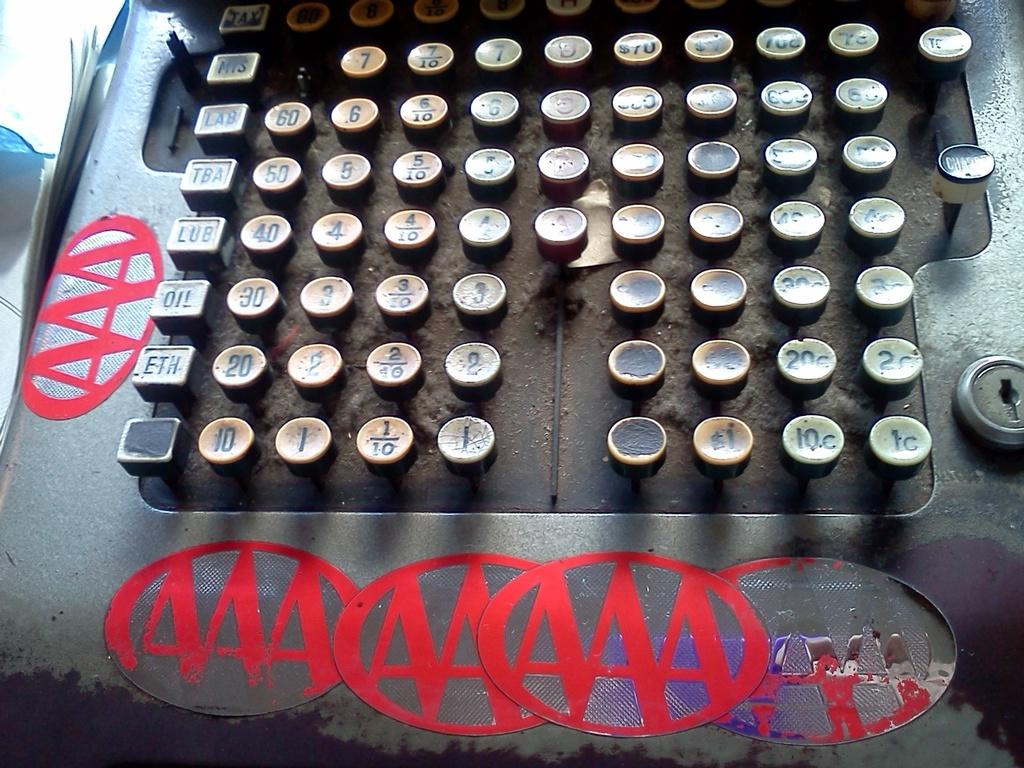<image>
Summarize the visual content of the image. An antique cash register with five old AAA stickers around the edges. 